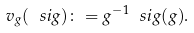<formula> <loc_0><loc_0><loc_500><loc_500>v _ { g } ( \ s i g ) \colon = g ^ { - 1 } \ s i g ( g ) .</formula> 